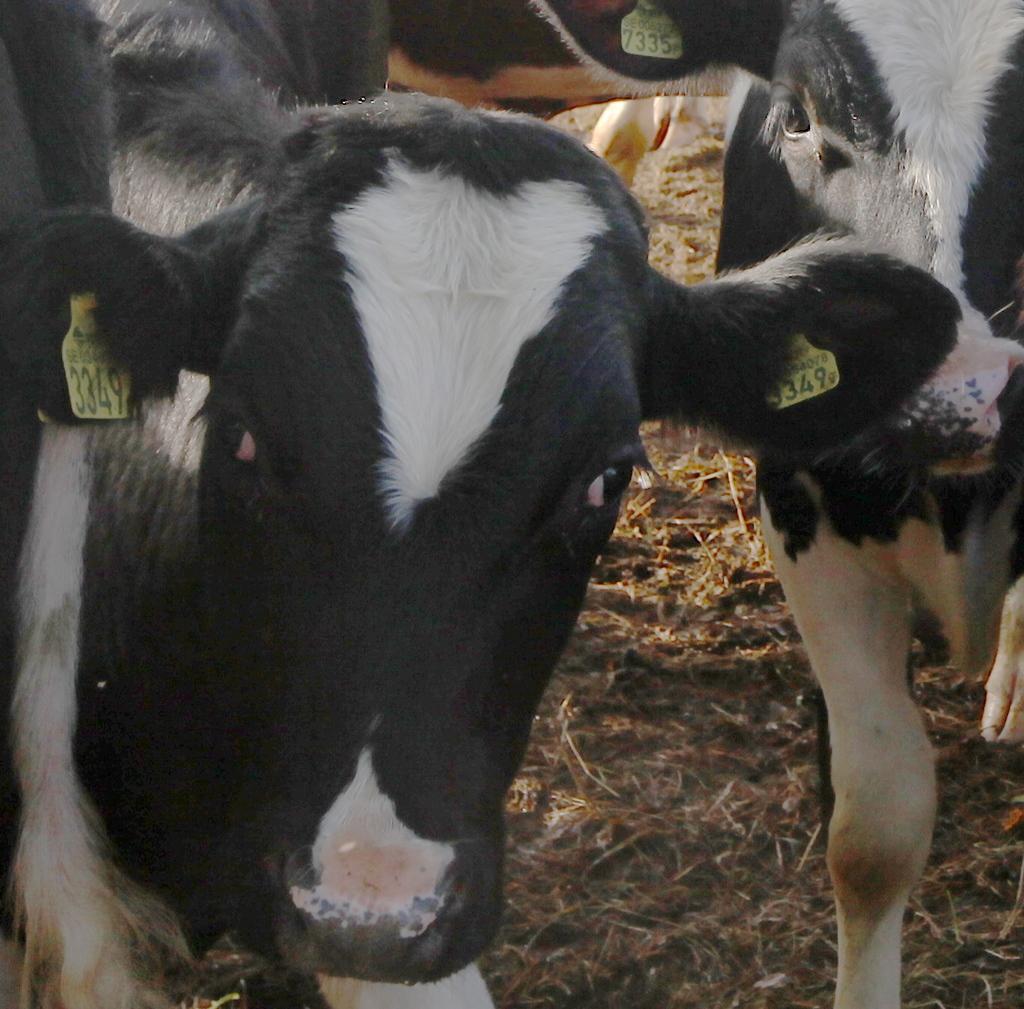Please provide a concise description of this image. In this image we see there are many cows looking at someone. 